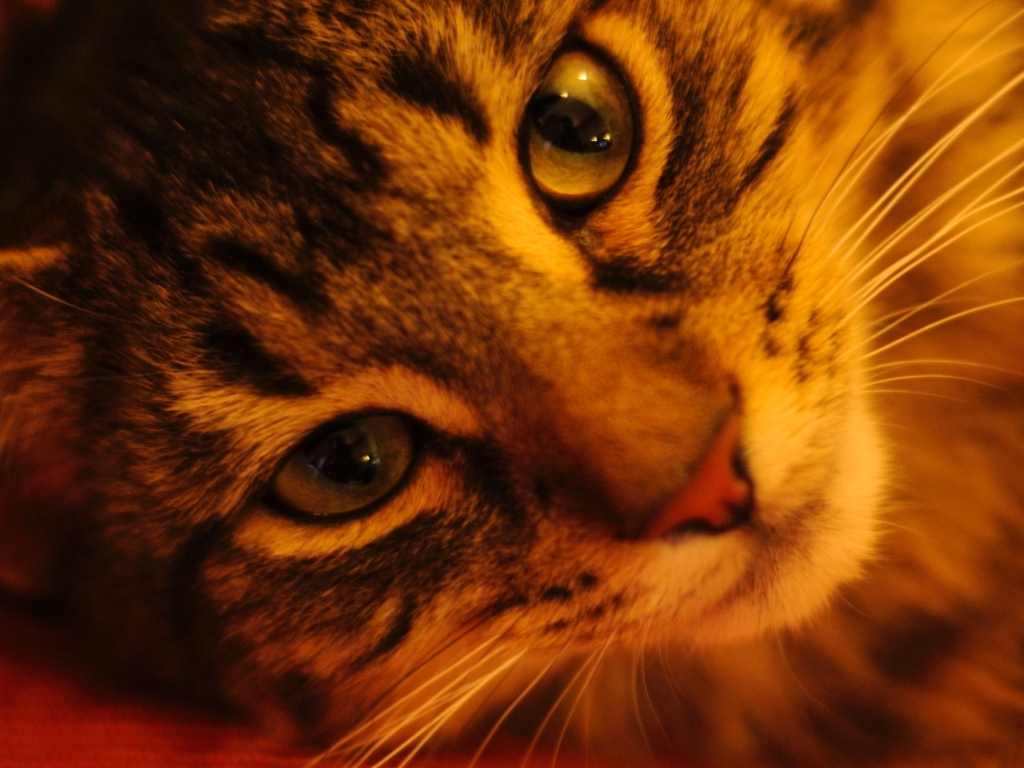What time of day does this photo suggest? Given the soft, warm lighting and the cat's relaxed demeanor, the photo suggests it could be taken during the evening hours when the household is winding down and lighting is often used to create a cozy atmosphere. 